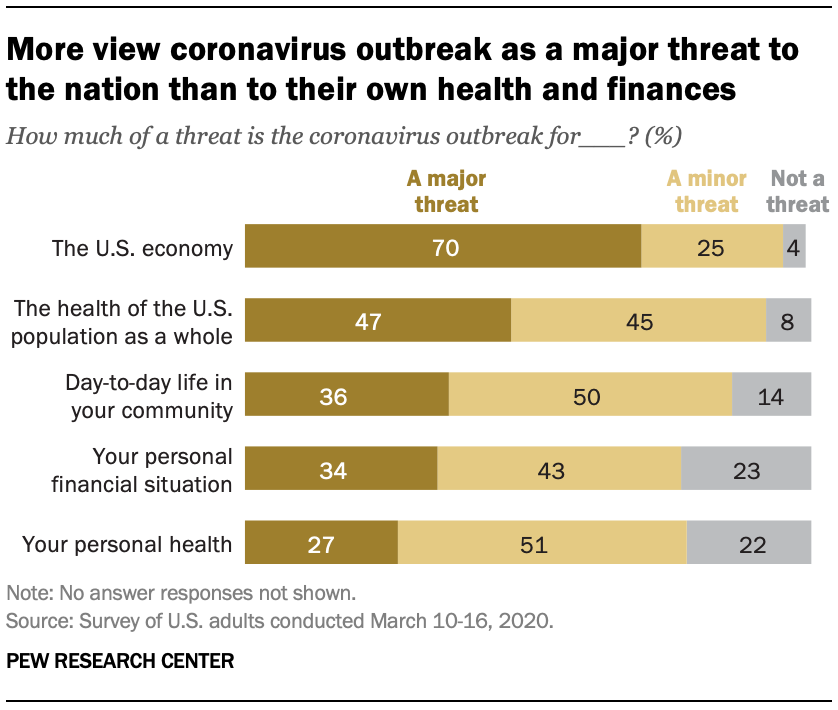Highlight a few significant elements in this photo. According to a recent survey, 43% of people believe that the coronavirus outbreak poses at least a minor threat to their personal financial situation. A majority of individuals believe that the COVID-19 pandemic poses a significant threat to the US economy, with 70% of people expressing this sentiment. 